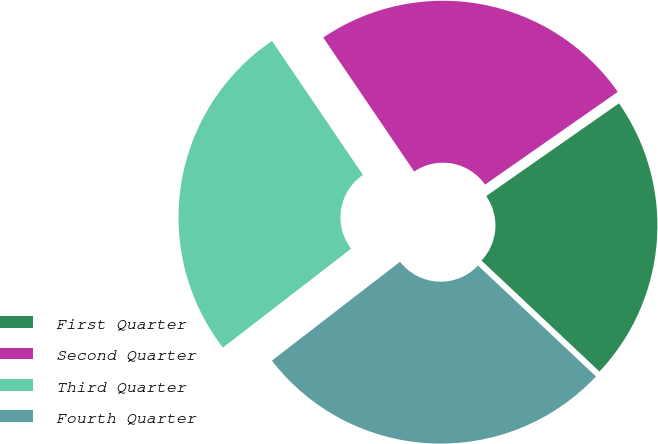<chart> <loc_0><loc_0><loc_500><loc_500><pie_chart><fcel>First Quarter<fcel>Second Quarter<fcel>Third Quarter<fcel>Fourth Quarter<nl><fcel>21.72%<fcel>24.79%<fcel>25.97%<fcel>27.53%<nl></chart> 